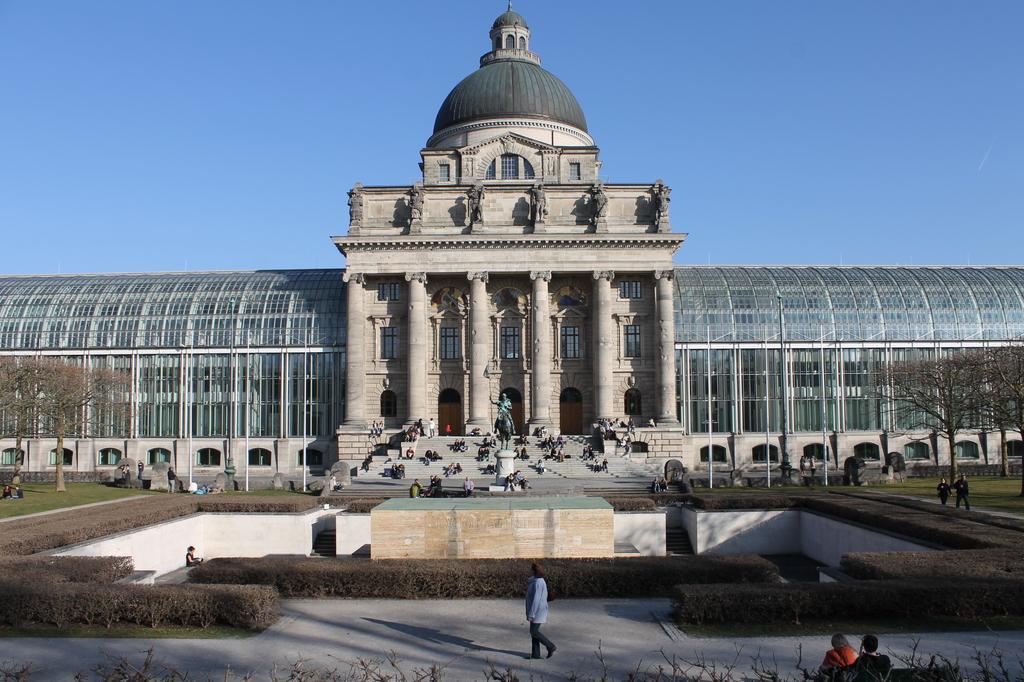Describe this image in one or two sentences. In this picture there is a building and there is a statue,few persons and a fountain in front of it and there are trees on either sides of it. 